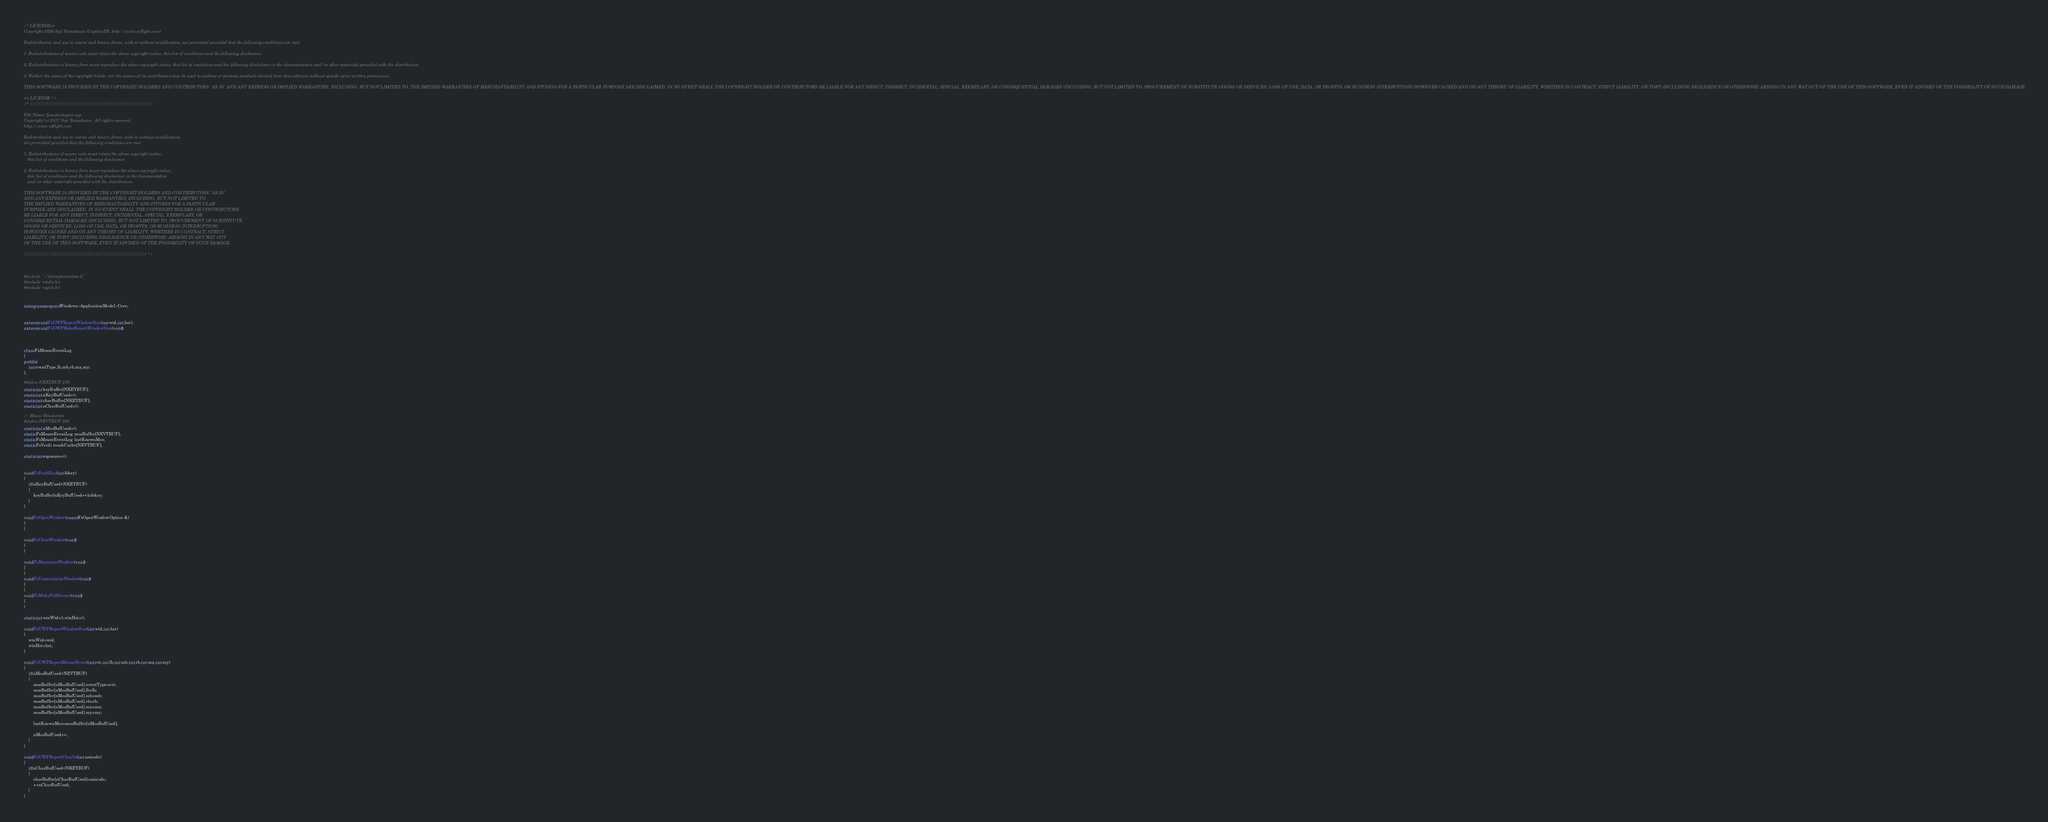Convert code to text. <code><loc_0><loc_0><loc_500><loc_500><_C++_>/* LICENSE>>
Copyright 2020 Soji Yamakawa (CaptainYS, http://www.ysflight.com)

Redistribution and use in source and binary forms, with or without modification, are permitted provided that the following conditions are met:

1. Redistributions of source code must retain the above copyright notice, this list of conditions and the following disclaimer.

2. Redistributions in binary form must reproduce the above copyright notice, this list of conditions and the following disclaimer in the documentation and/or other materials provided with the distribution.

3. Neither the name of the copyright holder nor the names of its contributors may be used to endorse or promote products derived from this software without specific prior written permission.

THIS SOFTWARE IS PROVIDED BY THE COPYRIGHT HOLDERS AND CONTRIBUTORS "AS IS" AND ANY EXPRESS OR IMPLIED WARRANTIES, INCLUDING, BUT NOT LIMITED TO, THE IMPLIED WARRANTIES OF MERCHANTABILITY AND FITNESS FOR A PARTICULAR PURPOSE ARE DISCLAIMED. IN NO EVENT SHALL THE COPYRIGHT HOLDER OR CONTRIBUTORS BE LIABLE FOR ANY DIRECT, INDIRECT, INCIDENTAL, SPECIAL, EXEMPLARY, OR CONSEQUENTIAL DAMAGES (INCLUDING, BUT NOT LIMITED TO, PROCUREMENT OF SUBSTITUTE GOODS OR SERVICES; LOSS OF USE, DATA, OR PROFITS; OR BUSINESS INTERRUPTION) HOWEVER CAUSED AND ON ANY THEORY OF LIABILITY, WHETHER IN CONTRACT, STRICT LIABILITY, OR TORT (INCLUDING NEGLIGENCE OR OTHERWISE) ARISING IN ANY WAY OUT OF THE USE OF THIS SOFTWARE, EVEN IF ADVISED OF THE POSSIBILITY OF SUCH DAMAGE.

<< LICENSE */
/* ////////////////////////////////////////////////////////////

File Name: fsuwpwrapper.cpp
Copyright (c) 2017 Soji Yamakawa.  All rights reserved.
http://www.ysflight.com

Redistribution and use in source and binary forms, with or without modification, 
are permitted provided that the following conditions are met:

1. Redistributions of source code must retain the above copyright notice, 
   this list of conditions and the following disclaimer.

2. Redistributions in binary form must reproduce the above copyright notice, 
   this list of conditions and the following disclaimer in the documentation 
   and/or other materials provided with the distribution.

THIS SOFTWARE IS PROVIDED BY THE COPYRIGHT HOLDERS AND CONTRIBUTORS "AS IS" 
AND ANY EXPRESS OR IMPLIED WARRANTIES, INCLUDING, BUT NOT LIMITED TO, 
THE IMPLIED WARRANTIES OF MERCHANTABILITY AND FITNESS FOR A PARTICULAR 
PURPOSE ARE DISCLAIMED. IN NO EVENT SHALL THE COPYRIGHT HOLDER OR CONTRIBUTORS 
BE LIABLE FOR ANY DIRECT, INDIRECT, INCIDENTAL, SPECIAL, EXEMPLARY, OR 
CONSEQUENTIAL DAMAGES (INCLUDING, BUT NOT LIMITED TO, PROCUREMENT OF SUBSTITUTE 
GOODS OR SERVICES; LOSS OF USE, DATA, OR PROFITS; OR BUSINESS INTERRUPTION) 
HOWEVER CAUSED AND ON ANY THEORY OF LIABILITY, WHETHER IN CONTRACT, STRICT 
LIABILITY, OR TORT (INCLUDING NEGLIGENCE OR OTHERWISE) ARISING IN ANY WAY OUT 
OF THE USE OF THIS SOFTWARE, EVEN IF ADVISED OF THE POSSIBILITY OF SUCH DAMAGE.

//////////////////////////////////////////////////////////// */



#include "../fssimplewindow.h"
#include <stdio.h>
#include <agile.h>


using namespace Windows::ApplicationModel::Core;


extern void FsUWPReportWindowSize(int wid,int hei);
extern void FsUWPMakeReportWindowSize(void);



class FsMouseEventLog
{
public:
	int eventType,lb,mb,rb,mx,my;
};

#define NKEYBUF 256
static int keyBuffer[NKEYBUF];
static int nKeyBufUsed=0;
static int charBuffer[NKEYBUF];
static int nCharBufUsed=0;

// Mouse Emulation
#define NEVTBUF 256
static int nMosBufUsed=0;
static FsMouseEventLog mosBuffer[NEVTBUF];
static FsMouseEventLog lastKnownMos;
static FsVec2i touchCache[NEVTBUF];

static int exposure=0;


void FsPushKey(int fskey)
{
	if(nKeyBufUsed<NKEYBUF)
	{
		keyBuffer[nKeyBufUsed++]=fskey;
	}
}

void FsOpenWindow(const FsOpenWindowOption &)
{
}

void FsCloseWindow(void)
{
}

void FsMaximizeWindow(void)
{
}
void FsUnmaximizeWindow(void)
{
}
void FsMakeFullScreen(void)
{
}

static int winWid=0,winHei=0;

void FsUWPReportWindowSize(int wid,int hei)
{
	winWid=wid;
	winHei=hei;
}

void FsUWPReportMouseEvent(int evt,int lb,int mb,int rb,int mx,int my)
{
	if(nMosBufUsed<NEVTBUF)
	{
		mosBuffer[nMosBufUsed].eventType=evt;
		mosBuffer[nMosBufUsed].lb=lb;
		mosBuffer[nMosBufUsed].mb=mb;
		mosBuffer[nMosBufUsed].rb=rb;
		mosBuffer[nMosBufUsed].mx=mx;
		mosBuffer[nMosBufUsed].my=my;

		lastKnownMos=mosBuffer[nMosBufUsed];

		nMosBufUsed++;
	}
}

void FsUWPReportCharIn(int unicode)
{
	if(nCharBufUsed<NKEYBUF)
	{
		charBuffer[nCharBufUsed]=unicode;
		++nCharBufUsed;
	}
}
</code> 